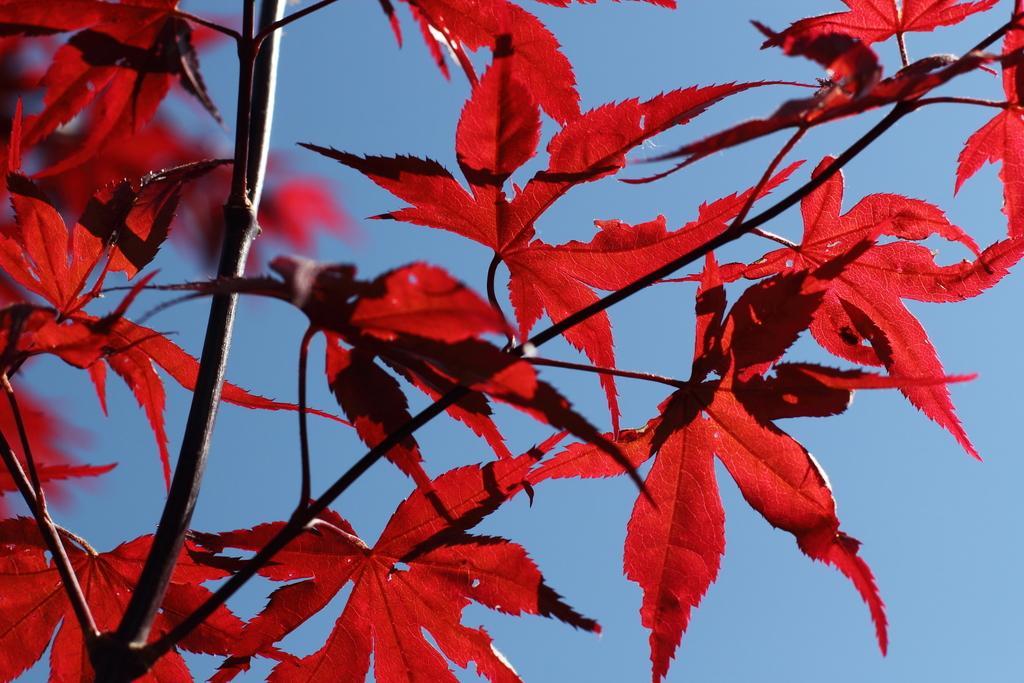Could you give a brief overview of what you see in this image? This image consists of a plant. To which we can see red color leaves. At the top, there is sky. 